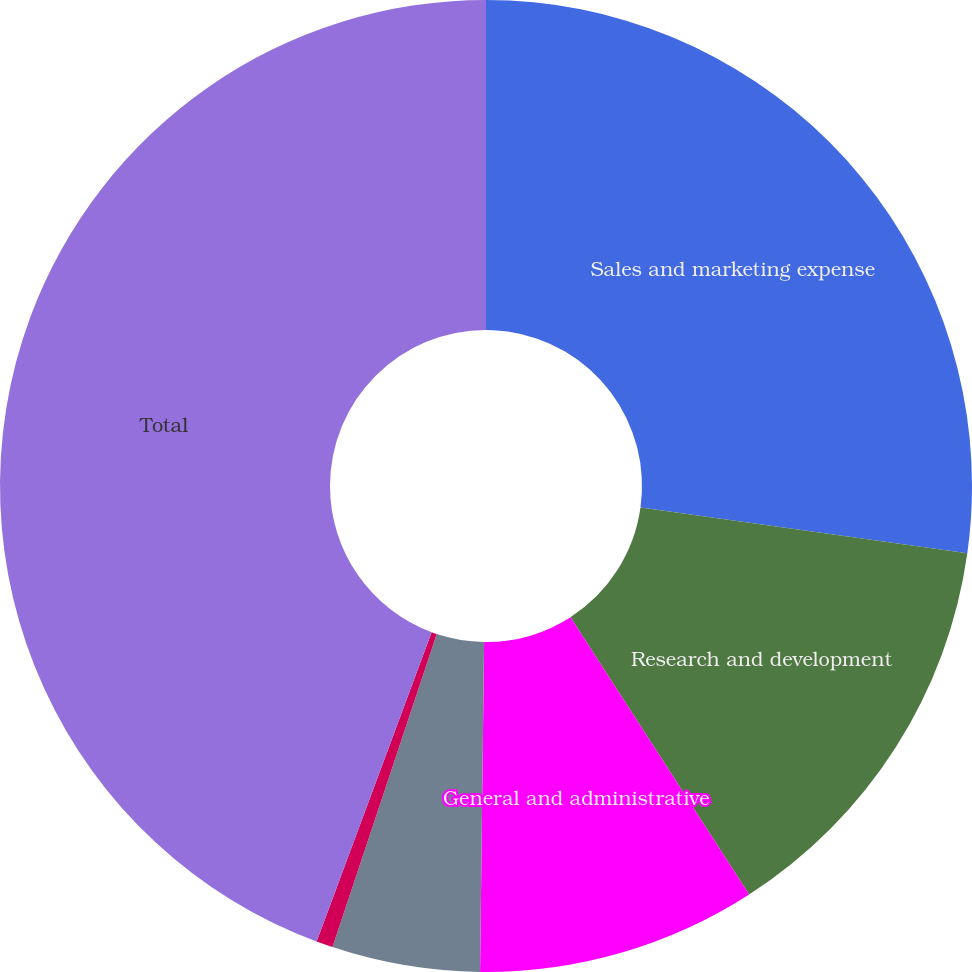<chart> <loc_0><loc_0><loc_500><loc_500><pie_chart><fcel>Sales and marketing expense<fcel>Research and development<fcel>General and administrative<fcel>Amortization of intangible<fcel>Restructuring and transition<fcel>Total<nl><fcel>27.21%<fcel>13.68%<fcel>9.3%<fcel>4.92%<fcel>0.55%<fcel>44.33%<nl></chart> 